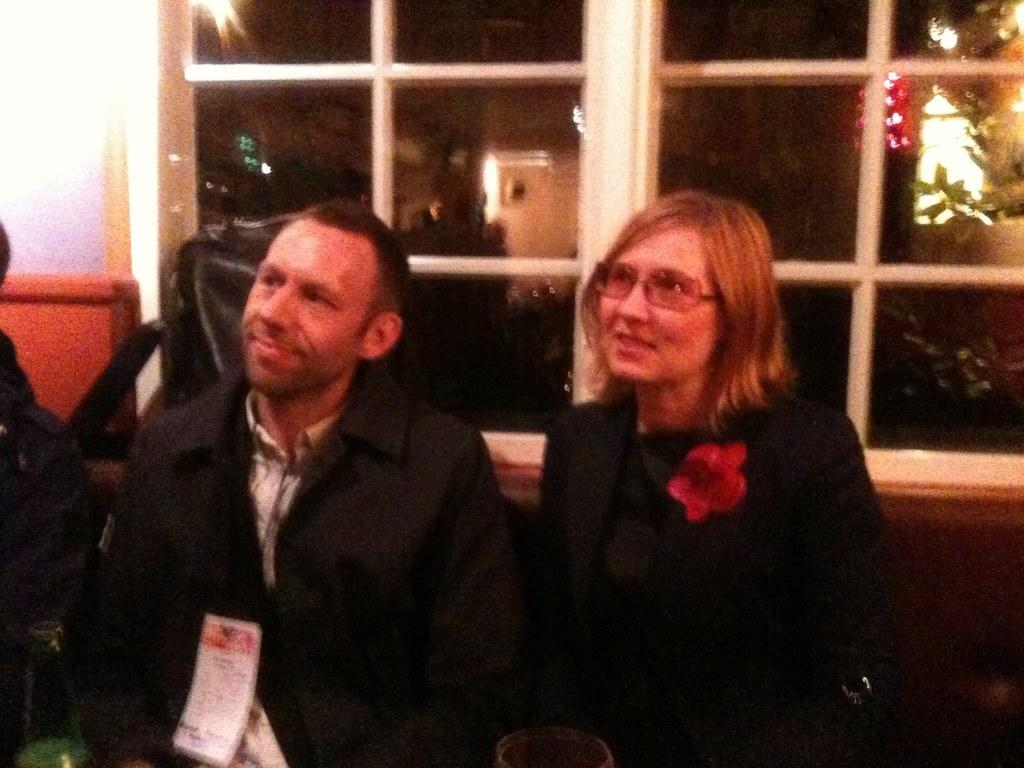What are the people in the image doing? The people in the image are sitting on a couch. Can you describe the background of the image? There is a glass window in the background of the image. What type of hydrant can be seen in the image? There is no hydrant present in the image. What is the interest of the people sitting on the couch in the image? The provided facts do not give any information about the interests of the people in the image. 